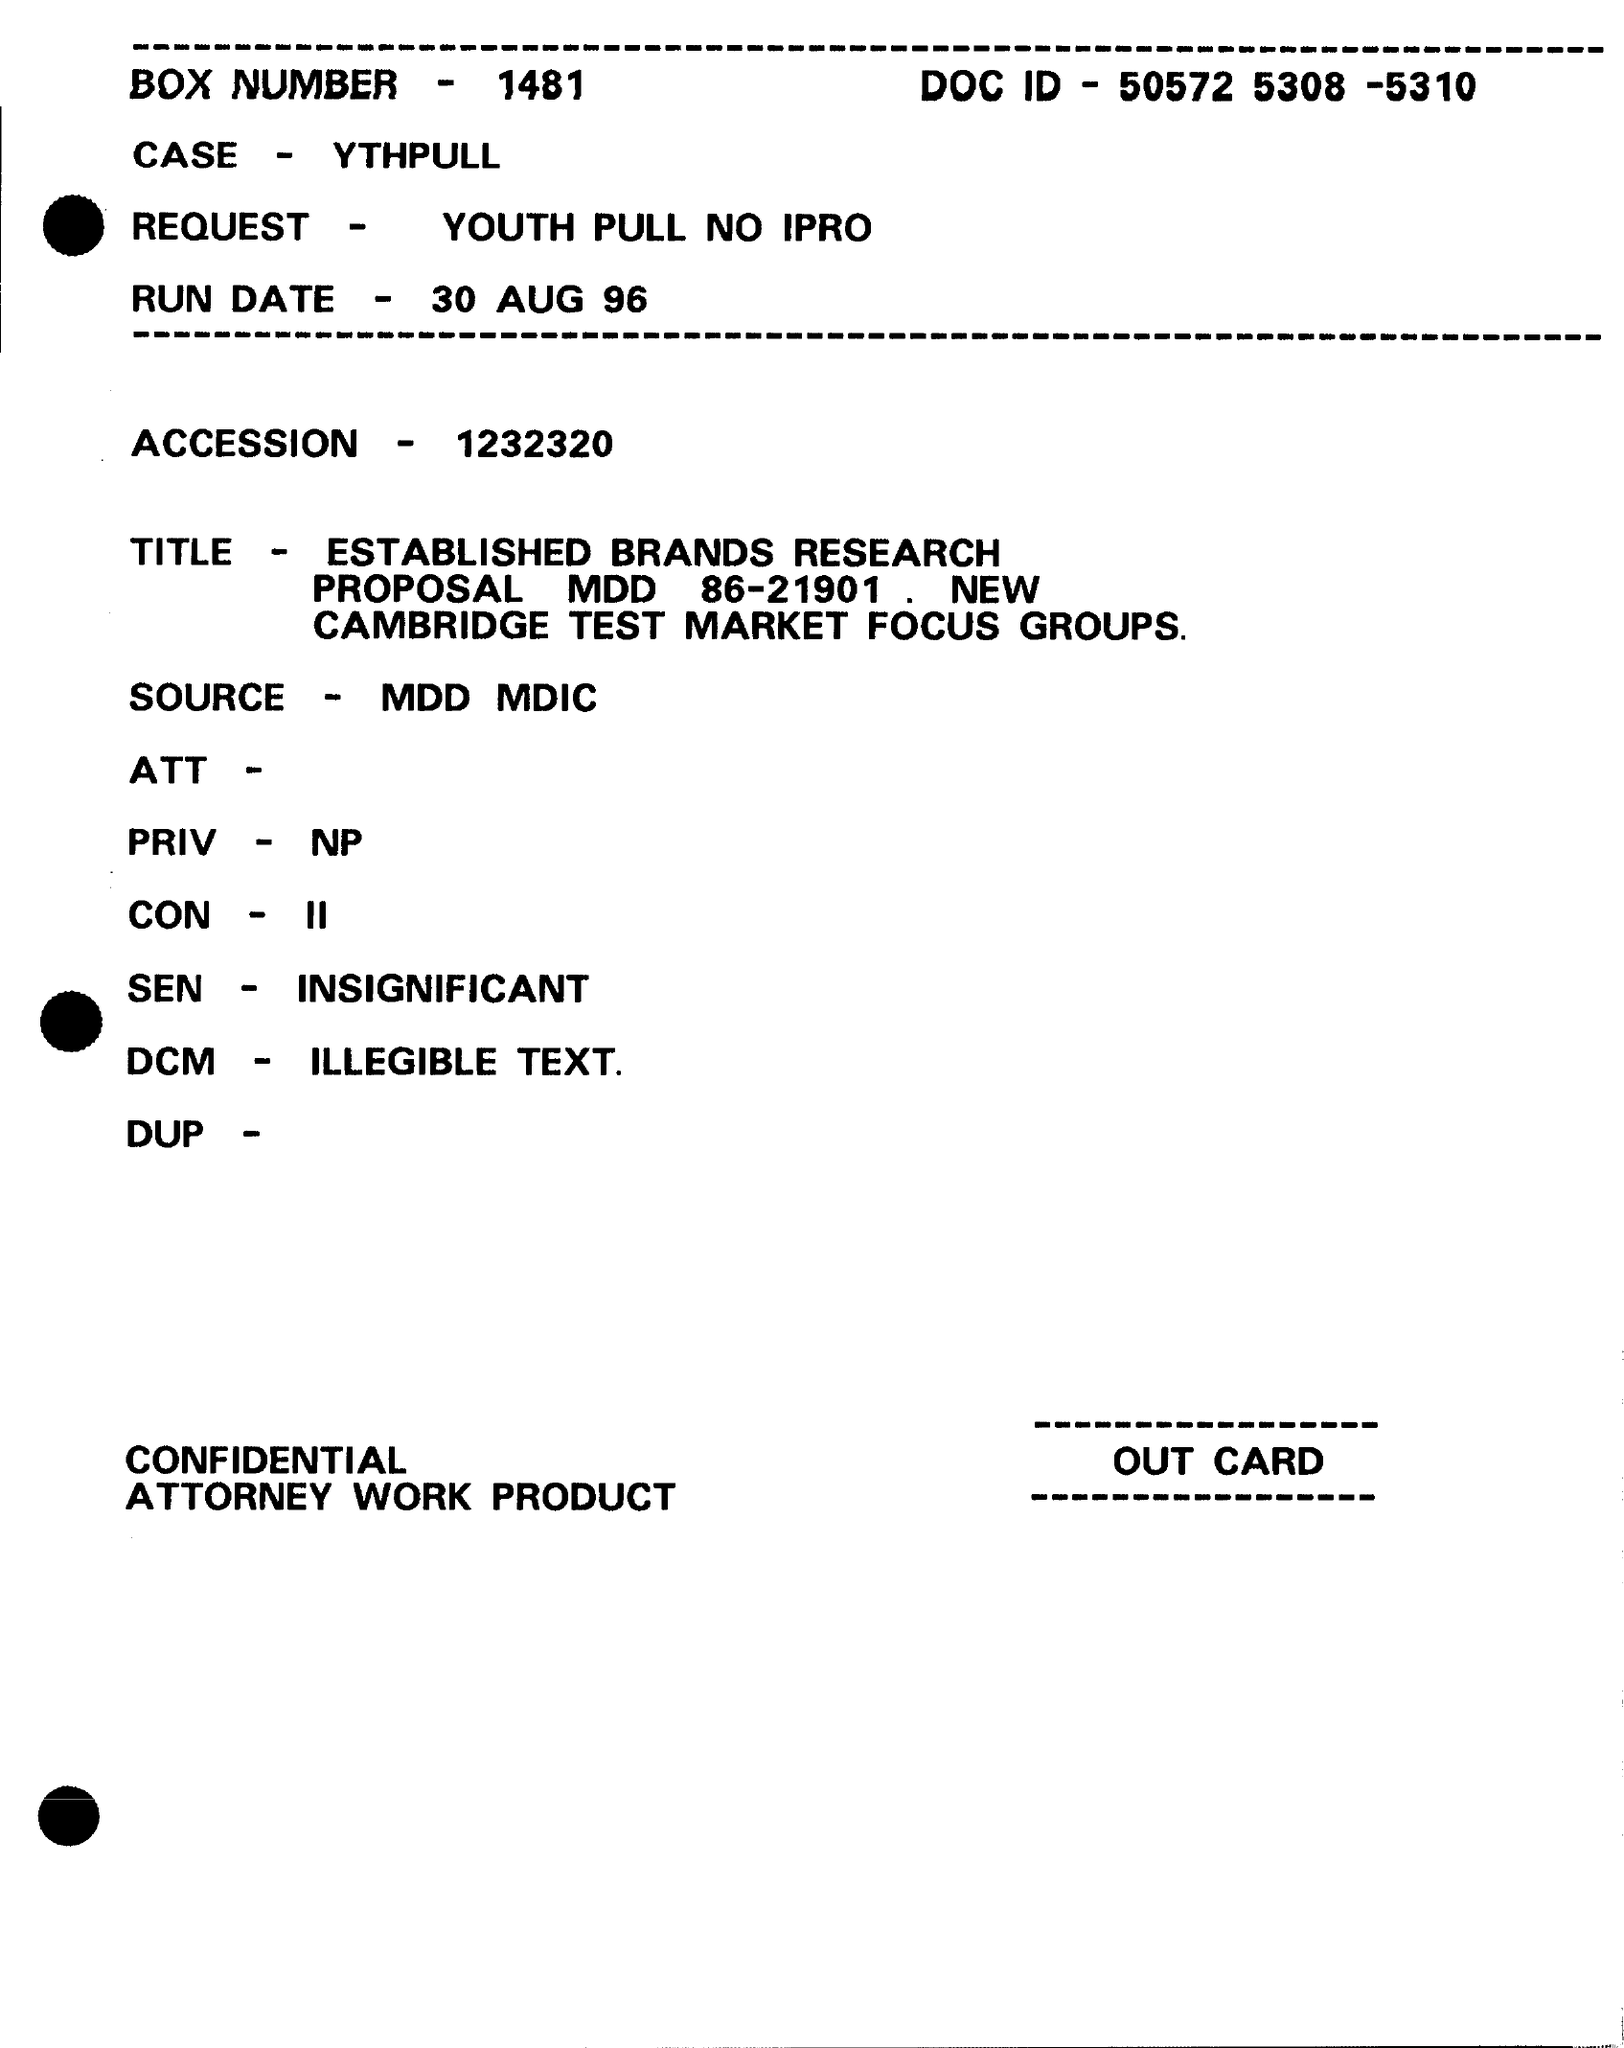Indicate a few pertinent items in this graphic. The BOX NUMBER is 1481. What is the case specified?" is a question asking for clarification or information about the specific situation being referred to. The request is for YOUTH PULL NO IPRO... The number in the ACCESSION field is 1232320... On August 30, 1996, a question was asked asking, 'What is the run date?' 